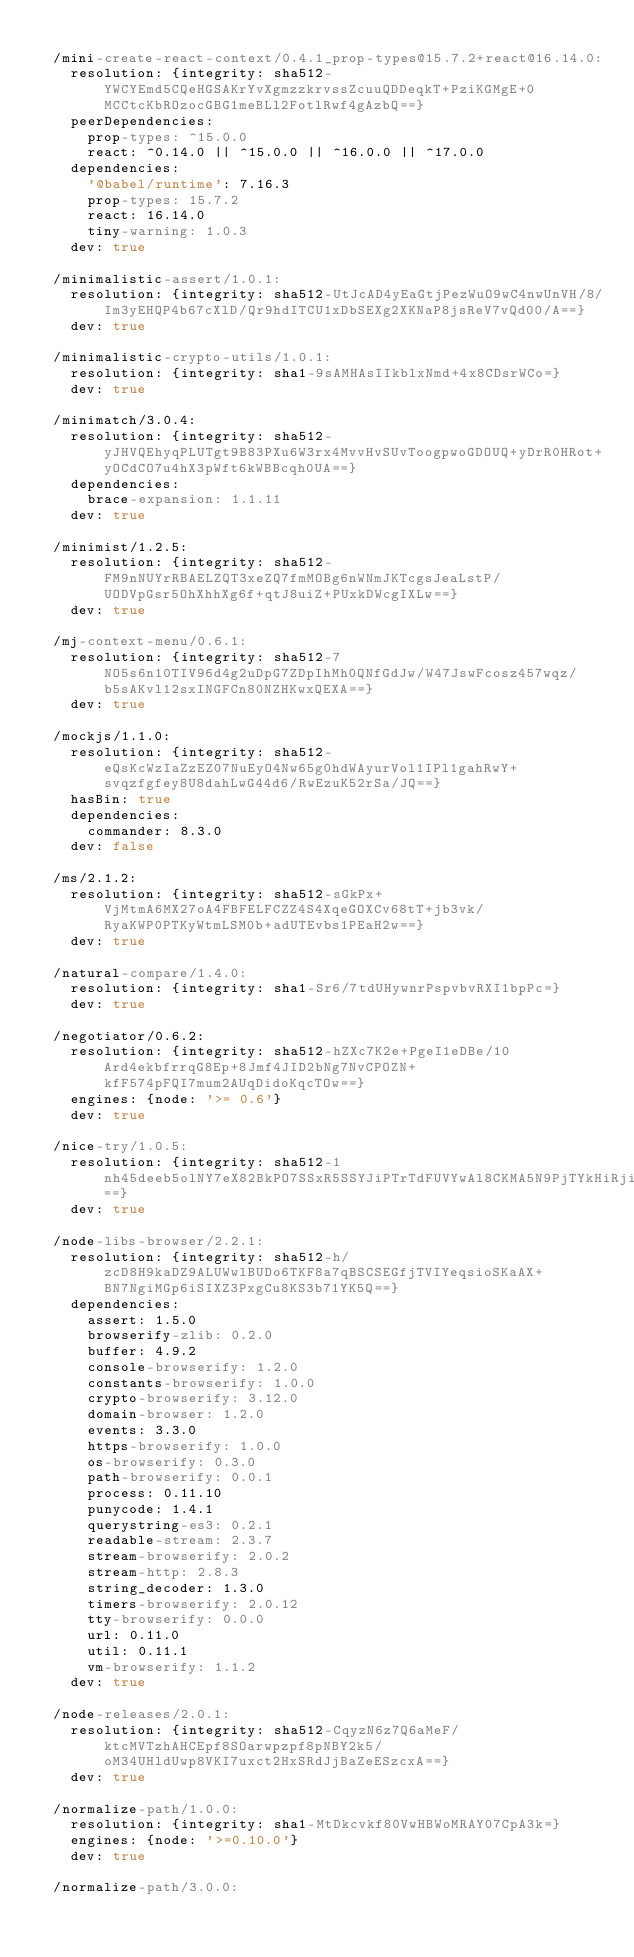Convert code to text. <code><loc_0><loc_0><loc_500><loc_500><_YAML_>
  /mini-create-react-context/0.4.1_prop-types@15.7.2+react@16.14.0:
    resolution: {integrity: sha512-YWCYEmd5CQeHGSAKrYvXgmzzkrvssZcuuQDDeqkT+PziKGMgE+0MCCtcKbROzocGBG1meBLl2FotlRwf4gAzbQ==}
    peerDependencies:
      prop-types: ^15.0.0
      react: ^0.14.0 || ^15.0.0 || ^16.0.0 || ^17.0.0
    dependencies:
      '@babel/runtime': 7.16.3
      prop-types: 15.7.2
      react: 16.14.0
      tiny-warning: 1.0.3
    dev: true

  /minimalistic-assert/1.0.1:
    resolution: {integrity: sha512-UtJcAD4yEaGtjPezWuO9wC4nwUnVH/8/Im3yEHQP4b67cXlD/Qr9hdITCU1xDbSEXg2XKNaP8jsReV7vQd00/A==}
    dev: true

  /minimalistic-crypto-utils/1.0.1:
    resolution: {integrity: sha1-9sAMHAsIIkblxNmd+4x8CDsrWCo=}
    dev: true

  /minimatch/3.0.4:
    resolution: {integrity: sha512-yJHVQEhyqPLUTgt9B83PXu6W3rx4MvvHvSUvToogpwoGDOUQ+yDrR0HRot+yOCdCO7u4hX3pWft6kWBBcqh0UA==}
    dependencies:
      brace-expansion: 1.1.11
    dev: true

  /minimist/1.2.5:
    resolution: {integrity: sha512-FM9nNUYrRBAELZQT3xeZQ7fmMOBg6nWNmJKTcgsJeaLstP/UODVpGsr5OhXhhXg6f+qtJ8uiZ+PUxkDWcgIXLw==}
    dev: true

  /mj-context-menu/0.6.1:
    resolution: {integrity: sha512-7NO5s6n10TIV96d4g2uDpG7ZDpIhMh0QNfGdJw/W47JswFcosz457wqz/b5sAKvl12sxINGFCn80NZHKwxQEXA==}
    dev: true

  /mockjs/1.1.0:
    resolution: {integrity: sha512-eQsKcWzIaZzEZ07NuEyO4Nw65g0hdWAyurVol1IPl1gahRwY+svqzfgfey8U8dahLwG44d6/RwEzuK52rSa/JQ==}
    hasBin: true
    dependencies:
      commander: 8.3.0
    dev: false

  /ms/2.1.2:
    resolution: {integrity: sha512-sGkPx+VjMtmA6MX27oA4FBFELFCZZ4S4XqeGOXCv68tT+jb3vk/RyaKWP0PTKyWtmLSM0b+adUTEvbs1PEaH2w==}
    dev: true

  /natural-compare/1.4.0:
    resolution: {integrity: sha1-Sr6/7tdUHywnrPspvbvRXI1bpPc=}
    dev: true

  /negotiator/0.6.2:
    resolution: {integrity: sha512-hZXc7K2e+PgeI1eDBe/10Ard4ekbfrrqG8Ep+8Jmf4JID2bNg7NvCPOZN+kfF574pFQI7mum2AUqDidoKqcTOw==}
    engines: {node: '>= 0.6'}
    dev: true

  /nice-try/1.0.5:
    resolution: {integrity: sha512-1nh45deeb5olNY7eX82BkPO7SSxR5SSYJiPTrTdFUVYwAl8CKMA5N9PjTYkHiRjisVcxcQ1HXdLhx2qxxJzLNQ==}
    dev: true

  /node-libs-browser/2.2.1:
    resolution: {integrity: sha512-h/zcD8H9kaDZ9ALUWwlBUDo6TKF8a7qBSCSEGfjTVIYeqsioSKaAX+BN7NgiMGp6iSIXZ3PxgCu8KS3b71YK5Q==}
    dependencies:
      assert: 1.5.0
      browserify-zlib: 0.2.0
      buffer: 4.9.2
      console-browserify: 1.2.0
      constants-browserify: 1.0.0
      crypto-browserify: 3.12.0
      domain-browser: 1.2.0
      events: 3.3.0
      https-browserify: 1.0.0
      os-browserify: 0.3.0
      path-browserify: 0.0.1
      process: 0.11.10
      punycode: 1.4.1
      querystring-es3: 0.2.1
      readable-stream: 2.3.7
      stream-browserify: 2.0.2
      stream-http: 2.8.3
      string_decoder: 1.3.0
      timers-browserify: 2.0.12
      tty-browserify: 0.0.0
      url: 0.11.0
      util: 0.11.1
      vm-browserify: 1.1.2
    dev: true

  /node-releases/2.0.1:
    resolution: {integrity: sha512-CqyzN6z7Q6aMeF/ktcMVTzhAHCEpf8SOarwpzpf8pNBY2k5/oM34UHldUwp8VKI7uxct2HxSRdJjBaZeESzcxA==}
    dev: true

  /normalize-path/1.0.0:
    resolution: {integrity: sha1-MtDkcvkf80VwHBWoMRAY07CpA3k=}
    engines: {node: '>=0.10.0'}
    dev: true

  /normalize-path/3.0.0:</code> 